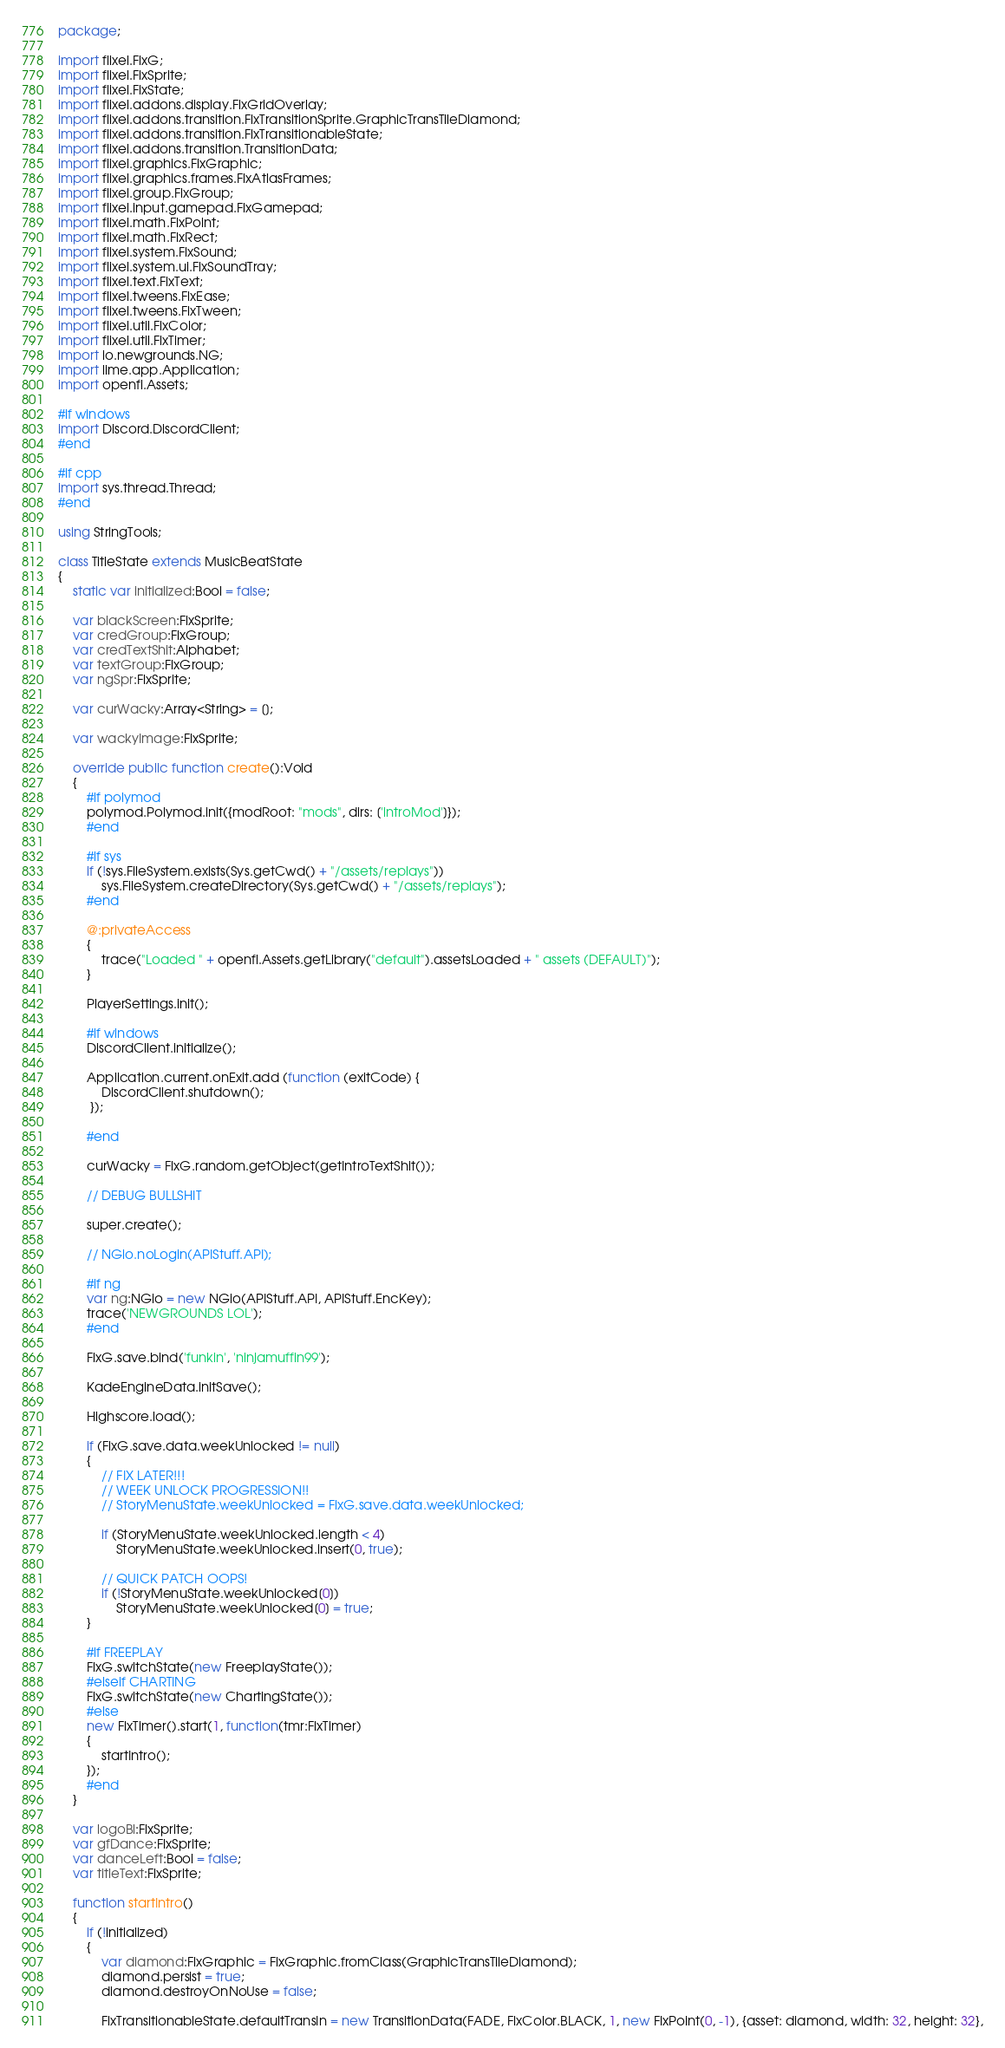<code> <loc_0><loc_0><loc_500><loc_500><_Haxe_>package;

import flixel.FlxG;
import flixel.FlxSprite;
import flixel.FlxState;
import flixel.addons.display.FlxGridOverlay;
import flixel.addons.transition.FlxTransitionSprite.GraphicTransTileDiamond;
import flixel.addons.transition.FlxTransitionableState;
import flixel.addons.transition.TransitionData;
import flixel.graphics.FlxGraphic;
import flixel.graphics.frames.FlxAtlasFrames;
import flixel.group.FlxGroup;
import flixel.input.gamepad.FlxGamepad;
import flixel.math.FlxPoint;
import flixel.math.FlxRect;
import flixel.system.FlxSound;
import flixel.system.ui.FlxSoundTray;
import flixel.text.FlxText;
import flixel.tweens.FlxEase;
import flixel.tweens.FlxTween;
import flixel.util.FlxColor;
import flixel.util.FlxTimer;
import io.newgrounds.NG;
import lime.app.Application;
import openfl.Assets;

#if windows
import Discord.DiscordClient;
#end

#if cpp
import sys.thread.Thread;
#end

using StringTools;

class TitleState extends MusicBeatState
{
	static var initialized:Bool = false;

	var blackScreen:FlxSprite;
	var credGroup:FlxGroup;
	var credTextShit:Alphabet;
	var textGroup:FlxGroup;
	var ngSpr:FlxSprite;

	var curWacky:Array<String> = [];

	var wackyImage:FlxSprite;

	override public function create():Void
	{
		#if polymod
		polymod.Polymod.init({modRoot: "mods", dirs: ['introMod']});
		#end
		
		#if sys
		if (!sys.FileSystem.exists(Sys.getCwd() + "/assets/replays"))
			sys.FileSystem.createDirectory(Sys.getCwd() + "/assets/replays");
		#end

		@:privateAccess
		{
			trace("Loaded " + openfl.Assets.getLibrary("default").assetsLoaded + " assets (DEFAULT)");
		}
		
		PlayerSettings.init();

		#if windows
		DiscordClient.initialize();

		Application.current.onExit.add (function (exitCode) {
			DiscordClient.shutdown();
		 });
		 
		#end

		curWacky = FlxG.random.getObject(getIntroTextShit());

		// DEBUG BULLSHIT

		super.create();

		// NGio.noLogin(APIStuff.API);

		#if ng
		var ng:NGio = new NGio(APIStuff.API, APIStuff.EncKey);
		trace('NEWGROUNDS LOL');
		#end

		FlxG.save.bind('funkin', 'ninjamuffin99');

		KadeEngineData.initSave();

		Highscore.load();

		if (FlxG.save.data.weekUnlocked != null)
		{
			// FIX LATER!!!
			// WEEK UNLOCK PROGRESSION!!
			// StoryMenuState.weekUnlocked = FlxG.save.data.weekUnlocked;

			if (StoryMenuState.weekUnlocked.length < 4)
				StoryMenuState.weekUnlocked.insert(0, true);

			// QUICK PATCH OOPS!
			if (!StoryMenuState.weekUnlocked[0])
				StoryMenuState.weekUnlocked[0] = true;
		}

		#if FREEPLAY
		FlxG.switchState(new FreeplayState());
		#elseif CHARTING
		FlxG.switchState(new ChartingState());
		#else
		new FlxTimer().start(1, function(tmr:FlxTimer)
		{
			startIntro();
		});
		#end
	}

	var logoBl:FlxSprite;
	var gfDance:FlxSprite;
	var danceLeft:Bool = false;
	var titleText:FlxSprite;

	function startIntro()
	{
		if (!initialized)
		{
			var diamond:FlxGraphic = FlxGraphic.fromClass(GraphicTransTileDiamond);
			diamond.persist = true;
			diamond.destroyOnNoUse = false;

			FlxTransitionableState.defaultTransIn = new TransitionData(FADE, FlxColor.BLACK, 1, new FlxPoint(0, -1), {asset: diamond, width: 32, height: 32},</code> 